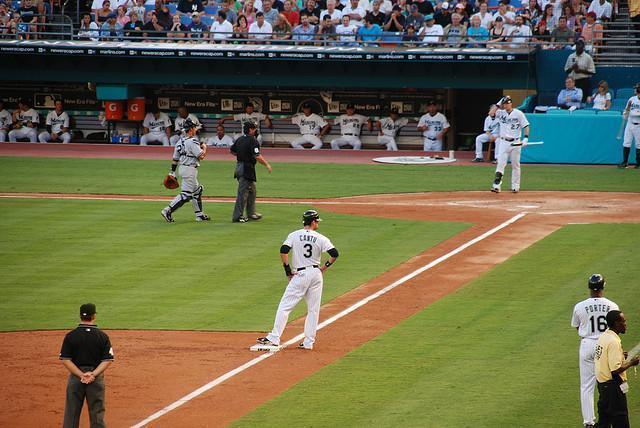What's the area where players are seated on a bench near gatorade coolers?
Make your selection and explain in format: 'Answer: answer
Rationale: rationale.'
Options: Dugout, locker room, home court, home base. Answer: dugout.
Rationale: The people are playing baseball. the players do not sit in the locker room during the game. 